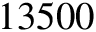<formula> <loc_0><loc_0><loc_500><loc_500>1 3 5 0 0</formula> 